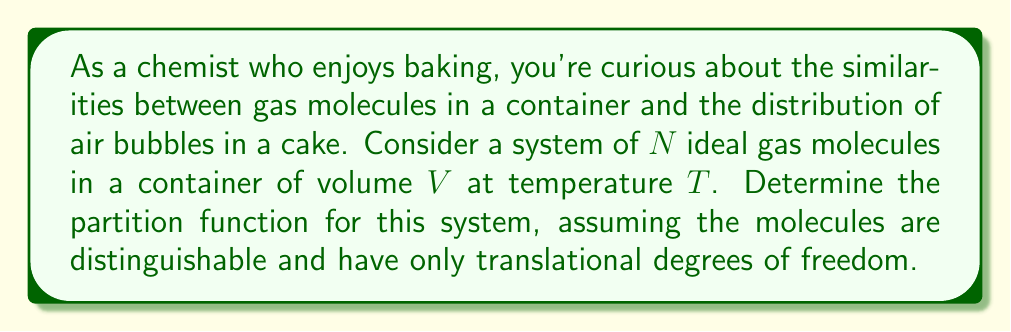Help me with this question. Let's approach this step-by-step:

1) For an ideal gas, we can treat each molecule independently. The total partition function will be the product of individual partition functions raised to the power of $N$.

2) For a single molecule with only translational degrees of freedom, the partition function is:

   $$Z_1 = \frac{V}{\Lambda^3}$$

   where $\Lambda = \frac{h}{\sqrt{2\pi mkT}}$ is the thermal de Broglie wavelength.

3) Here, $h$ is Planck's constant, $m$ is the mass of a molecule, $k$ is Boltzmann's constant, and $T$ is the temperature.

4) For $N$ distinguishable particles, the total partition function is:

   $$Z = (Z_1)^N = \left(\frac{V}{\Lambda^3}\right)^N$$

5) Expanding this:

   $$Z = \frac{V^N}{(\Lambda^3)^N} = \frac{V^N}{\Lambda^{3N}}$$

6) Substituting the expression for $\Lambda$:

   $$Z = \frac{V^N}{\left(\frac{h}{\sqrt{2\pi mkT}}\right)^{3N}}$$

7) Simplifying:

   $$Z = \frac{V^N (2\pi mkT)^{3N/2}}{h^{3N}}$$

This is the partition function for a system of $N$ ideal gas molecules in a volume $V$ at temperature $T$.
Answer: $$Z = \frac{V^N (2\pi mkT)^{3N/2}}{h^{3N}}$$ 